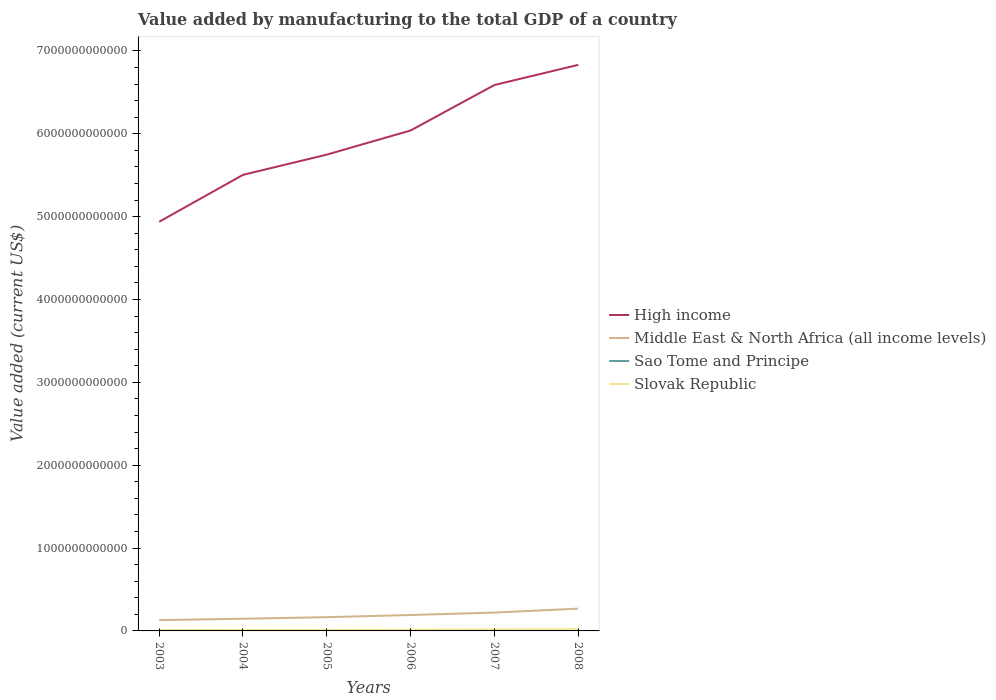How many different coloured lines are there?
Give a very brief answer. 4. Does the line corresponding to Sao Tome and Principe intersect with the line corresponding to Middle East & North Africa (all income levels)?
Keep it short and to the point. No. Is the number of lines equal to the number of legend labels?
Your response must be concise. Yes. Across all years, what is the maximum value added by manufacturing to the total GDP in High income?
Ensure brevity in your answer.  4.94e+12. What is the total value added by manufacturing to the total GDP in Sao Tome and Principe in the graph?
Your response must be concise. -6.07e+05. What is the difference between the highest and the second highest value added by manufacturing to the total GDP in Slovak Republic?
Give a very brief answer. 1.06e+1. How many years are there in the graph?
Provide a short and direct response. 6. What is the difference between two consecutive major ticks on the Y-axis?
Your answer should be compact. 1.00e+12. How many legend labels are there?
Give a very brief answer. 4. What is the title of the graph?
Your answer should be very brief. Value added by manufacturing to the total GDP of a country. What is the label or title of the X-axis?
Make the answer very short. Years. What is the label or title of the Y-axis?
Provide a short and direct response. Value added (current US$). What is the Value added (current US$) of High income in 2003?
Give a very brief answer. 4.94e+12. What is the Value added (current US$) in Middle East & North Africa (all income levels) in 2003?
Provide a short and direct response. 1.31e+11. What is the Value added (current US$) of Sao Tome and Principe in 2003?
Give a very brief answer. 6.55e+06. What is the Value added (current US$) of Slovak Republic in 2003?
Ensure brevity in your answer.  9.63e+09. What is the Value added (current US$) of High income in 2004?
Give a very brief answer. 5.50e+12. What is the Value added (current US$) in Middle East & North Africa (all income levels) in 2004?
Ensure brevity in your answer.  1.47e+11. What is the Value added (current US$) in Sao Tome and Principe in 2004?
Offer a very short reply. 6.38e+06. What is the Value added (current US$) in Slovak Republic in 2004?
Keep it short and to the point. 1.21e+1. What is the Value added (current US$) in High income in 2005?
Your answer should be very brief. 5.75e+12. What is the Value added (current US$) in Middle East & North Africa (all income levels) in 2005?
Keep it short and to the point. 1.66e+11. What is the Value added (current US$) of Sao Tome and Principe in 2005?
Provide a short and direct response. 6.79e+06. What is the Value added (current US$) of Slovak Republic in 2005?
Provide a short and direct response. 1.31e+1. What is the Value added (current US$) in High income in 2006?
Ensure brevity in your answer.  6.04e+12. What is the Value added (current US$) of Middle East & North Africa (all income levels) in 2006?
Provide a succinct answer. 1.92e+11. What is the Value added (current US$) in Sao Tome and Principe in 2006?
Offer a very short reply. 6.99e+06. What is the Value added (current US$) in Slovak Republic in 2006?
Ensure brevity in your answer.  1.49e+1. What is the Value added (current US$) of High income in 2007?
Provide a succinct answer. 6.59e+12. What is the Value added (current US$) in Middle East & North Africa (all income levels) in 2007?
Offer a very short reply. 2.21e+11. What is the Value added (current US$) in Sao Tome and Principe in 2007?
Provide a short and direct response. 7.11e+06. What is the Value added (current US$) of Slovak Republic in 2007?
Provide a short and direct response. 1.81e+1. What is the Value added (current US$) of High income in 2008?
Offer a very short reply. 6.83e+12. What is the Value added (current US$) in Middle East & North Africa (all income levels) in 2008?
Ensure brevity in your answer.  2.69e+11. What is the Value added (current US$) in Sao Tome and Principe in 2008?
Your answer should be very brief. 1.15e+07. What is the Value added (current US$) of Slovak Republic in 2008?
Your answer should be very brief. 2.03e+1. Across all years, what is the maximum Value added (current US$) of High income?
Provide a succinct answer. 6.83e+12. Across all years, what is the maximum Value added (current US$) of Middle East & North Africa (all income levels)?
Offer a terse response. 2.69e+11. Across all years, what is the maximum Value added (current US$) of Sao Tome and Principe?
Give a very brief answer. 1.15e+07. Across all years, what is the maximum Value added (current US$) in Slovak Republic?
Offer a very short reply. 2.03e+1. Across all years, what is the minimum Value added (current US$) in High income?
Offer a very short reply. 4.94e+12. Across all years, what is the minimum Value added (current US$) in Middle East & North Africa (all income levels)?
Keep it short and to the point. 1.31e+11. Across all years, what is the minimum Value added (current US$) of Sao Tome and Principe?
Provide a succinct answer. 6.38e+06. Across all years, what is the minimum Value added (current US$) in Slovak Republic?
Provide a short and direct response. 9.63e+09. What is the total Value added (current US$) of High income in the graph?
Your answer should be compact. 3.56e+13. What is the total Value added (current US$) in Middle East & North Africa (all income levels) in the graph?
Your answer should be compact. 1.13e+12. What is the total Value added (current US$) in Sao Tome and Principe in the graph?
Provide a short and direct response. 4.53e+07. What is the total Value added (current US$) of Slovak Republic in the graph?
Make the answer very short. 8.81e+1. What is the difference between the Value added (current US$) in High income in 2003 and that in 2004?
Offer a terse response. -5.66e+11. What is the difference between the Value added (current US$) in Middle East & North Africa (all income levels) in 2003 and that in 2004?
Your answer should be very brief. -1.64e+1. What is the difference between the Value added (current US$) in Sao Tome and Principe in 2003 and that in 2004?
Keep it short and to the point. 1.73e+05. What is the difference between the Value added (current US$) of Slovak Republic in 2003 and that in 2004?
Keep it short and to the point. -2.42e+09. What is the difference between the Value added (current US$) in High income in 2003 and that in 2005?
Make the answer very short. -8.10e+11. What is the difference between the Value added (current US$) in Middle East & North Africa (all income levels) in 2003 and that in 2005?
Provide a succinct answer. -3.54e+1. What is the difference between the Value added (current US$) of Sao Tome and Principe in 2003 and that in 2005?
Offer a very short reply. -2.34e+05. What is the difference between the Value added (current US$) of Slovak Republic in 2003 and that in 2005?
Make the answer very short. -3.47e+09. What is the difference between the Value added (current US$) of High income in 2003 and that in 2006?
Your answer should be compact. -1.10e+12. What is the difference between the Value added (current US$) of Middle East & North Africa (all income levels) in 2003 and that in 2006?
Make the answer very short. -6.12e+1. What is the difference between the Value added (current US$) in Sao Tome and Principe in 2003 and that in 2006?
Offer a very short reply. -4.34e+05. What is the difference between the Value added (current US$) in Slovak Republic in 2003 and that in 2006?
Keep it short and to the point. -5.31e+09. What is the difference between the Value added (current US$) in High income in 2003 and that in 2007?
Keep it short and to the point. -1.65e+12. What is the difference between the Value added (current US$) in Middle East & North Africa (all income levels) in 2003 and that in 2007?
Provide a short and direct response. -9.07e+1. What is the difference between the Value added (current US$) of Sao Tome and Principe in 2003 and that in 2007?
Offer a very short reply. -5.55e+05. What is the difference between the Value added (current US$) of Slovak Republic in 2003 and that in 2007?
Make the answer very short. -8.48e+09. What is the difference between the Value added (current US$) in High income in 2003 and that in 2008?
Provide a short and direct response. -1.89e+12. What is the difference between the Value added (current US$) in Middle East & North Africa (all income levels) in 2003 and that in 2008?
Ensure brevity in your answer.  -1.38e+11. What is the difference between the Value added (current US$) of Sao Tome and Principe in 2003 and that in 2008?
Keep it short and to the point. -4.90e+06. What is the difference between the Value added (current US$) in Slovak Republic in 2003 and that in 2008?
Offer a terse response. -1.06e+1. What is the difference between the Value added (current US$) of High income in 2004 and that in 2005?
Keep it short and to the point. -2.44e+11. What is the difference between the Value added (current US$) of Middle East & North Africa (all income levels) in 2004 and that in 2005?
Your answer should be very brief. -1.90e+1. What is the difference between the Value added (current US$) in Sao Tome and Principe in 2004 and that in 2005?
Offer a very short reply. -4.07e+05. What is the difference between the Value added (current US$) in Slovak Republic in 2004 and that in 2005?
Your response must be concise. -1.05e+09. What is the difference between the Value added (current US$) of High income in 2004 and that in 2006?
Provide a short and direct response. -5.35e+11. What is the difference between the Value added (current US$) of Middle East & North Africa (all income levels) in 2004 and that in 2006?
Your answer should be very brief. -4.48e+1. What is the difference between the Value added (current US$) in Sao Tome and Principe in 2004 and that in 2006?
Make the answer very short. -6.07e+05. What is the difference between the Value added (current US$) of Slovak Republic in 2004 and that in 2006?
Offer a very short reply. -2.88e+09. What is the difference between the Value added (current US$) in High income in 2004 and that in 2007?
Provide a succinct answer. -1.08e+12. What is the difference between the Value added (current US$) in Middle East & North Africa (all income levels) in 2004 and that in 2007?
Provide a succinct answer. -7.43e+1. What is the difference between the Value added (current US$) in Sao Tome and Principe in 2004 and that in 2007?
Provide a succinct answer. -7.28e+05. What is the difference between the Value added (current US$) in Slovak Republic in 2004 and that in 2007?
Provide a short and direct response. -6.06e+09. What is the difference between the Value added (current US$) of High income in 2004 and that in 2008?
Make the answer very short. -1.33e+12. What is the difference between the Value added (current US$) in Middle East & North Africa (all income levels) in 2004 and that in 2008?
Your answer should be compact. -1.22e+11. What is the difference between the Value added (current US$) of Sao Tome and Principe in 2004 and that in 2008?
Keep it short and to the point. -5.08e+06. What is the difference between the Value added (current US$) of Slovak Republic in 2004 and that in 2008?
Offer a terse response. -8.20e+09. What is the difference between the Value added (current US$) of High income in 2005 and that in 2006?
Your answer should be compact. -2.91e+11. What is the difference between the Value added (current US$) in Middle East & North Africa (all income levels) in 2005 and that in 2006?
Make the answer very short. -2.58e+1. What is the difference between the Value added (current US$) of Sao Tome and Principe in 2005 and that in 2006?
Your response must be concise. -2.00e+05. What is the difference between the Value added (current US$) of Slovak Republic in 2005 and that in 2006?
Provide a succinct answer. -1.83e+09. What is the difference between the Value added (current US$) of High income in 2005 and that in 2007?
Keep it short and to the point. -8.40e+11. What is the difference between the Value added (current US$) in Middle East & North Africa (all income levels) in 2005 and that in 2007?
Your response must be concise. -5.53e+1. What is the difference between the Value added (current US$) in Sao Tome and Principe in 2005 and that in 2007?
Your answer should be very brief. -3.21e+05. What is the difference between the Value added (current US$) of Slovak Republic in 2005 and that in 2007?
Offer a very short reply. -5.00e+09. What is the difference between the Value added (current US$) in High income in 2005 and that in 2008?
Offer a terse response. -1.08e+12. What is the difference between the Value added (current US$) in Middle East & North Africa (all income levels) in 2005 and that in 2008?
Offer a very short reply. -1.03e+11. What is the difference between the Value added (current US$) of Sao Tome and Principe in 2005 and that in 2008?
Offer a terse response. -4.67e+06. What is the difference between the Value added (current US$) of Slovak Republic in 2005 and that in 2008?
Provide a succinct answer. -7.15e+09. What is the difference between the Value added (current US$) of High income in 2006 and that in 2007?
Your answer should be very brief. -5.49e+11. What is the difference between the Value added (current US$) of Middle East & North Africa (all income levels) in 2006 and that in 2007?
Provide a succinct answer. -2.95e+1. What is the difference between the Value added (current US$) of Sao Tome and Principe in 2006 and that in 2007?
Your answer should be compact. -1.21e+05. What is the difference between the Value added (current US$) in Slovak Republic in 2006 and that in 2007?
Offer a very short reply. -3.17e+09. What is the difference between the Value added (current US$) of High income in 2006 and that in 2008?
Provide a succinct answer. -7.92e+11. What is the difference between the Value added (current US$) of Middle East & North Africa (all income levels) in 2006 and that in 2008?
Make the answer very short. -7.68e+1. What is the difference between the Value added (current US$) in Sao Tome and Principe in 2006 and that in 2008?
Offer a very short reply. -4.47e+06. What is the difference between the Value added (current US$) of Slovak Republic in 2006 and that in 2008?
Keep it short and to the point. -5.32e+09. What is the difference between the Value added (current US$) of High income in 2007 and that in 2008?
Keep it short and to the point. -2.43e+11. What is the difference between the Value added (current US$) of Middle East & North Africa (all income levels) in 2007 and that in 2008?
Keep it short and to the point. -4.74e+1. What is the difference between the Value added (current US$) in Sao Tome and Principe in 2007 and that in 2008?
Your answer should be very brief. -4.35e+06. What is the difference between the Value added (current US$) of Slovak Republic in 2007 and that in 2008?
Offer a very short reply. -2.14e+09. What is the difference between the Value added (current US$) in High income in 2003 and the Value added (current US$) in Middle East & North Africa (all income levels) in 2004?
Give a very brief answer. 4.79e+12. What is the difference between the Value added (current US$) in High income in 2003 and the Value added (current US$) in Sao Tome and Principe in 2004?
Your response must be concise. 4.94e+12. What is the difference between the Value added (current US$) of High income in 2003 and the Value added (current US$) of Slovak Republic in 2004?
Provide a short and direct response. 4.93e+12. What is the difference between the Value added (current US$) of Middle East & North Africa (all income levels) in 2003 and the Value added (current US$) of Sao Tome and Principe in 2004?
Make the answer very short. 1.31e+11. What is the difference between the Value added (current US$) of Middle East & North Africa (all income levels) in 2003 and the Value added (current US$) of Slovak Republic in 2004?
Your response must be concise. 1.19e+11. What is the difference between the Value added (current US$) of Sao Tome and Principe in 2003 and the Value added (current US$) of Slovak Republic in 2004?
Provide a short and direct response. -1.20e+1. What is the difference between the Value added (current US$) in High income in 2003 and the Value added (current US$) in Middle East & North Africa (all income levels) in 2005?
Your response must be concise. 4.77e+12. What is the difference between the Value added (current US$) of High income in 2003 and the Value added (current US$) of Sao Tome and Principe in 2005?
Make the answer very short. 4.94e+12. What is the difference between the Value added (current US$) in High income in 2003 and the Value added (current US$) in Slovak Republic in 2005?
Offer a very short reply. 4.92e+12. What is the difference between the Value added (current US$) in Middle East & North Africa (all income levels) in 2003 and the Value added (current US$) in Sao Tome and Principe in 2005?
Make the answer very short. 1.31e+11. What is the difference between the Value added (current US$) in Middle East & North Africa (all income levels) in 2003 and the Value added (current US$) in Slovak Republic in 2005?
Give a very brief answer. 1.18e+11. What is the difference between the Value added (current US$) in Sao Tome and Principe in 2003 and the Value added (current US$) in Slovak Republic in 2005?
Your response must be concise. -1.31e+1. What is the difference between the Value added (current US$) in High income in 2003 and the Value added (current US$) in Middle East & North Africa (all income levels) in 2006?
Your answer should be very brief. 4.75e+12. What is the difference between the Value added (current US$) of High income in 2003 and the Value added (current US$) of Sao Tome and Principe in 2006?
Make the answer very short. 4.94e+12. What is the difference between the Value added (current US$) in High income in 2003 and the Value added (current US$) in Slovak Republic in 2006?
Offer a very short reply. 4.92e+12. What is the difference between the Value added (current US$) in Middle East & North Africa (all income levels) in 2003 and the Value added (current US$) in Sao Tome and Principe in 2006?
Your answer should be very brief. 1.31e+11. What is the difference between the Value added (current US$) of Middle East & North Africa (all income levels) in 2003 and the Value added (current US$) of Slovak Republic in 2006?
Offer a terse response. 1.16e+11. What is the difference between the Value added (current US$) of Sao Tome and Principe in 2003 and the Value added (current US$) of Slovak Republic in 2006?
Your response must be concise. -1.49e+1. What is the difference between the Value added (current US$) in High income in 2003 and the Value added (current US$) in Middle East & North Africa (all income levels) in 2007?
Your answer should be very brief. 4.72e+12. What is the difference between the Value added (current US$) of High income in 2003 and the Value added (current US$) of Sao Tome and Principe in 2007?
Offer a terse response. 4.94e+12. What is the difference between the Value added (current US$) in High income in 2003 and the Value added (current US$) in Slovak Republic in 2007?
Your answer should be very brief. 4.92e+12. What is the difference between the Value added (current US$) of Middle East & North Africa (all income levels) in 2003 and the Value added (current US$) of Sao Tome and Principe in 2007?
Your answer should be very brief. 1.31e+11. What is the difference between the Value added (current US$) of Middle East & North Africa (all income levels) in 2003 and the Value added (current US$) of Slovak Republic in 2007?
Ensure brevity in your answer.  1.13e+11. What is the difference between the Value added (current US$) in Sao Tome and Principe in 2003 and the Value added (current US$) in Slovak Republic in 2007?
Your response must be concise. -1.81e+1. What is the difference between the Value added (current US$) in High income in 2003 and the Value added (current US$) in Middle East & North Africa (all income levels) in 2008?
Your response must be concise. 4.67e+12. What is the difference between the Value added (current US$) in High income in 2003 and the Value added (current US$) in Sao Tome and Principe in 2008?
Your answer should be compact. 4.94e+12. What is the difference between the Value added (current US$) in High income in 2003 and the Value added (current US$) in Slovak Republic in 2008?
Offer a very short reply. 4.92e+12. What is the difference between the Value added (current US$) in Middle East & North Africa (all income levels) in 2003 and the Value added (current US$) in Sao Tome and Principe in 2008?
Ensure brevity in your answer.  1.31e+11. What is the difference between the Value added (current US$) of Middle East & North Africa (all income levels) in 2003 and the Value added (current US$) of Slovak Republic in 2008?
Make the answer very short. 1.10e+11. What is the difference between the Value added (current US$) in Sao Tome and Principe in 2003 and the Value added (current US$) in Slovak Republic in 2008?
Your answer should be very brief. -2.02e+1. What is the difference between the Value added (current US$) of High income in 2004 and the Value added (current US$) of Middle East & North Africa (all income levels) in 2005?
Provide a succinct answer. 5.34e+12. What is the difference between the Value added (current US$) in High income in 2004 and the Value added (current US$) in Sao Tome and Principe in 2005?
Offer a terse response. 5.50e+12. What is the difference between the Value added (current US$) in High income in 2004 and the Value added (current US$) in Slovak Republic in 2005?
Your answer should be compact. 5.49e+12. What is the difference between the Value added (current US$) of Middle East & North Africa (all income levels) in 2004 and the Value added (current US$) of Sao Tome and Principe in 2005?
Keep it short and to the point. 1.47e+11. What is the difference between the Value added (current US$) in Middle East & North Africa (all income levels) in 2004 and the Value added (current US$) in Slovak Republic in 2005?
Offer a terse response. 1.34e+11. What is the difference between the Value added (current US$) in Sao Tome and Principe in 2004 and the Value added (current US$) in Slovak Republic in 2005?
Make the answer very short. -1.31e+1. What is the difference between the Value added (current US$) of High income in 2004 and the Value added (current US$) of Middle East & North Africa (all income levels) in 2006?
Provide a short and direct response. 5.31e+12. What is the difference between the Value added (current US$) in High income in 2004 and the Value added (current US$) in Sao Tome and Principe in 2006?
Your answer should be very brief. 5.50e+12. What is the difference between the Value added (current US$) of High income in 2004 and the Value added (current US$) of Slovak Republic in 2006?
Your answer should be very brief. 5.49e+12. What is the difference between the Value added (current US$) in Middle East & North Africa (all income levels) in 2004 and the Value added (current US$) in Sao Tome and Principe in 2006?
Your answer should be compact. 1.47e+11. What is the difference between the Value added (current US$) in Middle East & North Africa (all income levels) in 2004 and the Value added (current US$) in Slovak Republic in 2006?
Keep it short and to the point. 1.32e+11. What is the difference between the Value added (current US$) in Sao Tome and Principe in 2004 and the Value added (current US$) in Slovak Republic in 2006?
Offer a very short reply. -1.49e+1. What is the difference between the Value added (current US$) in High income in 2004 and the Value added (current US$) in Middle East & North Africa (all income levels) in 2007?
Give a very brief answer. 5.28e+12. What is the difference between the Value added (current US$) of High income in 2004 and the Value added (current US$) of Sao Tome and Principe in 2007?
Your answer should be very brief. 5.50e+12. What is the difference between the Value added (current US$) of High income in 2004 and the Value added (current US$) of Slovak Republic in 2007?
Offer a very short reply. 5.49e+12. What is the difference between the Value added (current US$) of Middle East & North Africa (all income levels) in 2004 and the Value added (current US$) of Sao Tome and Principe in 2007?
Provide a short and direct response. 1.47e+11. What is the difference between the Value added (current US$) in Middle East & North Africa (all income levels) in 2004 and the Value added (current US$) in Slovak Republic in 2007?
Keep it short and to the point. 1.29e+11. What is the difference between the Value added (current US$) of Sao Tome and Principe in 2004 and the Value added (current US$) of Slovak Republic in 2007?
Keep it short and to the point. -1.81e+1. What is the difference between the Value added (current US$) of High income in 2004 and the Value added (current US$) of Middle East & North Africa (all income levels) in 2008?
Keep it short and to the point. 5.24e+12. What is the difference between the Value added (current US$) in High income in 2004 and the Value added (current US$) in Sao Tome and Principe in 2008?
Provide a succinct answer. 5.50e+12. What is the difference between the Value added (current US$) in High income in 2004 and the Value added (current US$) in Slovak Republic in 2008?
Your answer should be compact. 5.48e+12. What is the difference between the Value added (current US$) in Middle East & North Africa (all income levels) in 2004 and the Value added (current US$) in Sao Tome and Principe in 2008?
Provide a succinct answer. 1.47e+11. What is the difference between the Value added (current US$) of Middle East & North Africa (all income levels) in 2004 and the Value added (current US$) of Slovak Republic in 2008?
Provide a succinct answer. 1.27e+11. What is the difference between the Value added (current US$) of Sao Tome and Principe in 2004 and the Value added (current US$) of Slovak Republic in 2008?
Provide a succinct answer. -2.02e+1. What is the difference between the Value added (current US$) in High income in 2005 and the Value added (current US$) in Middle East & North Africa (all income levels) in 2006?
Offer a very short reply. 5.56e+12. What is the difference between the Value added (current US$) of High income in 2005 and the Value added (current US$) of Sao Tome and Principe in 2006?
Provide a short and direct response. 5.75e+12. What is the difference between the Value added (current US$) in High income in 2005 and the Value added (current US$) in Slovak Republic in 2006?
Your response must be concise. 5.73e+12. What is the difference between the Value added (current US$) of Middle East & North Africa (all income levels) in 2005 and the Value added (current US$) of Sao Tome and Principe in 2006?
Make the answer very short. 1.66e+11. What is the difference between the Value added (current US$) of Middle East & North Africa (all income levels) in 2005 and the Value added (current US$) of Slovak Republic in 2006?
Provide a short and direct response. 1.51e+11. What is the difference between the Value added (current US$) in Sao Tome and Principe in 2005 and the Value added (current US$) in Slovak Republic in 2006?
Give a very brief answer. -1.49e+1. What is the difference between the Value added (current US$) of High income in 2005 and the Value added (current US$) of Middle East & North Africa (all income levels) in 2007?
Provide a succinct answer. 5.53e+12. What is the difference between the Value added (current US$) in High income in 2005 and the Value added (current US$) in Sao Tome and Principe in 2007?
Give a very brief answer. 5.75e+12. What is the difference between the Value added (current US$) in High income in 2005 and the Value added (current US$) in Slovak Republic in 2007?
Your answer should be very brief. 5.73e+12. What is the difference between the Value added (current US$) in Middle East & North Africa (all income levels) in 2005 and the Value added (current US$) in Sao Tome and Principe in 2007?
Keep it short and to the point. 1.66e+11. What is the difference between the Value added (current US$) of Middle East & North Africa (all income levels) in 2005 and the Value added (current US$) of Slovak Republic in 2007?
Ensure brevity in your answer.  1.48e+11. What is the difference between the Value added (current US$) of Sao Tome and Principe in 2005 and the Value added (current US$) of Slovak Republic in 2007?
Offer a very short reply. -1.81e+1. What is the difference between the Value added (current US$) in High income in 2005 and the Value added (current US$) in Middle East & North Africa (all income levels) in 2008?
Your answer should be very brief. 5.48e+12. What is the difference between the Value added (current US$) in High income in 2005 and the Value added (current US$) in Sao Tome and Principe in 2008?
Your response must be concise. 5.75e+12. What is the difference between the Value added (current US$) in High income in 2005 and the Value added (current US$) in Slovak Republic in 2008?
Offer a terse response. 5.73e+12. What is the difference between the Value added (current US$) in Middle East & North Africa (all income levels) in 2005 and the Value added (current US$) in Sao Tome and Principe in 2008?
Your answer should be compact. 1.66e+11. What is the difference between the Value added (current US$) in Middle East & North Africa (all income levels) in 2005 and the Value added (current US$) in Slovak Republic in 2008?
Ensure brevity in your answer.  1.46e+11. What is the difference between the Value added (current US$) of Sao Tome and Principe in 2005 and the Value added (current US$) of Slovak Republic in 2008?
Give a very brief answer. -2.02e+1. What is the difference between the Value added (current US$) in High income in 2006 and the Value added (current US$) in Middle East & North Africa (all income levels) in 2007?
Give a very brief answer. 5.82e+12. What is the difference between the Value added (current US$) of High income in 2006 and the Value added (current US$) of Sao Tome and Principe in 2007?
Your answer should be compact. 6.04e+12. What is the difference between the Value added (current US$) of High income in 2006 and the Value added (current US$) of Slovak Republic in 2007?
Your answer should be compact. 6.02e+12. What is the difference between the Value added (current US$) of Middle East & North Africa (all income levels) in 2006 and the Value added (current US$) of Sao Tome and Principe in 2007?
Make the answer very short. 1.92e+11. What is the difference between the Value added (current US$) of Middle East & North Africa (all income levels) in 2006 and the Value added (current US$) of Slovak Republic in 2007?
Ensure brevity in your answer.  1.74e+11. What is the difference between the Value added (current US$) in Sao Tome and Principe in 2006 and the Value added (current US$) in Slovak Republic in 2007?
Your answer should be compact. -1.81e+1. What is the difference between the Value added (current US$) of High income in 2006 and the Value added (current US$) of Middle East & North Africa (all income levels) in 2008?
Offer a very short reply. 5.77e+12. What is the difference between the Value added (current US$) in High income in 2006 and the Value added (current US$) in Sao Tome and Principe in 2008?
Keep it short and to the point. 6.04e+12. What is the difference between the Value added (current US$) of High income in 2006 and the Value added (current US$) of Slovak Republic in 2008?
Offer a terse response. 6.02e+12. What is the difference between the Value added (current US$) in Middle East & North Africa (all income levels) in 2006 and the Value added (current US$) in Sao Tome and Principe in 2008?
Make the answer very short. 1.92e+11. What is the difference between the Value added (current US$) in Middle East & North Africa (all income levels) in 2006 and the Value added (current US$) in Slovak Republic in 2008?
Provide a succinct answer. 1.72e+11. What is the difference between the Value added (current US$) of Sao Tome and Principe in 2006 and the Value added (current US$) of Slovak Republic in 2008?
Ensure brevity in your answer.  -2.02e+1. What is the difference between the Value added (current US$) of High income in 2007 and the Value added (current US$) of Middle East & North Africa (all income levels) in 2008?
Your response must be concise. 6.32e+12. What is the difference between the Value added (current US$) in High income in 2007 and the Value added (current US$) in Sao Tome and Principe in 2008?
Offer a very short reply. 6.59e+12. What is the difference between the Value added (current US$) in High income in 2007 and the Value added (current US$) in Slovak Republic in 2008?
Provide a short and direct response. 6.57e+12. What is the difference between the Value added (current US$) in Middle East & North Africa (all income levels) in 2007 and the Value added (current US$) in Sao Tome and Principe in 2008?
Your response must be concise. 2.21e+11. What is the difference between the Value added (current US$) in Middle East & North Africa (all income levels) in 2007 and the Value added (current US$) in Slovak Republic in 2008?
Offer a very short reply. 2.01e+11. What is the difference between the Value added (current US$) in Sao Tome and Principe in 2007 and the Value added (current US$) in Slovak Republic in 2008?
Offer a terse response. -2.02e+1. What is the average Value added (current US$) of High income per year?
Offer a very short reply. 5.94e+12. What is the average Value added (current US$) in Middle East & North Africa (all income levels) per year?
Your answer should be very brief. 1.88e+11. What is the average Value added (current US$) in Sao Tome and Principe per year?
Offer a terse response. 7.55e+06. What is the average Value added (current US$) in Slovak Republic per year?
Provide a succinct answer. 1.47e+1. In the year 2003, what is the difference between the Value added (current US$) in High income and Value added (current US$) in Middle East & North Africa (all income levels)?
Offer a very short reply. 4.81e+12. In the year 2003, what is the difference between the Value added (current US$) of High income and Value added (current US$) of Sao Tome and Principe?
Offer a very short reply. 4.94e+12. In the year 2003, what is the difference between the Value added (current US$) of High income and Value added (current US$) of Slovak Republic?
Give a very brief answer. 4.93e+12. In the year 2003, what is the difference between the Value added (current US$) of Middle East & North Africa (all income levels) and Value added (current US$) of Sao Tome and Principe?
Your answer should be very brief. 1.31e+11. In the year 2003, what is the difference between the Value added (current US$) of Middle East & North Africa (all income levels) and Value added (current US$) of Slovak Republic?
Offer a terse response. 1.21e+11. In the year 2003, what is the difference between the Value added (current US$) in Sao Tome and Principe and Value added (current US$) in Slovak Republic?
Your answer should be compact. -9.63e+09. In the year 2004, what is the difference between the Value added (current US$) in High income and Value added (current US$) in Middle East & North Africa (all income levels)?
Your answer should be compact. 5.36e+12. In the year 2004, what is the difference between the Value added (current US$) in High income and Value added (current US$) in Sao Tome and Principe?
Make the answer very short. 5.50e+12. In the year 2004, what is the difference between the Value added (current US$) in High income and Value added (current US$) in Slovak Republic?
Provide a short and direct response. 5.49e+12. In the year 2004, what is the difference between the Value added (current US$) of Middle East & North Africa (all income levels) and Value added (current US$) of Sao Tome and Principe?
Give a very brief answer. 1.47e+11. In the year 2004, what is the difference between the Value added (current US$) of Middle East & North Africa (all income levels) and Value added (current US$) of Slovak Republic?
Your answer should be very brief. 1.35e+11. In the year 2004, what is the difference between the Value added (current US$) in Sao Tome and Principe and Value added (current US$) in Slovak Republic?
Offer a very short reply. -1.20e+1. In the year 2005, what is the difference between the Value added (current US$) in High income and Value added (current US$) in Middle East & North Africa (all income levels)?
Your response must be concise. 5.58e+12. In the year 2005, what is the difference between the Value added (current US$) in High income and Value added (current US$) in Sao Tome and Principe?
Offer a terse response. 5.75e+12. In the year 2005, what is the difference between the Value added (current US$) in High income and Value added (current US$) in Slovak Republic?
Keep it short and to the point. 5.74e+12. In the year 2005, what is the difference between the Value added (current US$) in Middle East & North Africa (all income levels) and Value added (current US$) in Sao Tome and Principe?
Your answer should be very brief. 1.66e+11. In the year 2005, what is the difference between the Value added (current US$) of Middle East & North Africa (all income levels) and Value added (current US$) of Slovak Republic?
Offer a terse response. 1.53e+11. In the year 2005, what is the difference between the Value added (current US$) in Sao Tome and Principe and Value added (current US$) in Slovak Republic?
Your answer should be compact. -1.31e+1. In the year 2006, what is the difference between the Value added (current US$) in High income and Value added (current US$) in Middle East & North Africa (all income levels)?
Your answer should be compact. 5.85e+12. In the year 2006, what is the difference between the Value added (current US$) in High income and Value added (current US$) in Sao Tome and Principe?
Ensure brevity in your answer.  6.04e+12. In the year 2006, what is the difference between the Value added (current US$) in High income and Value added (current US$) in Slovak Republic?
Your response must be concise. 6.02e+12. In the year 2006, what is the difference between the Value added (current US$) of Middle East & North Africa (all income levels) and Value added (current US$) of Sao Tome and Principe?
Offer a very short reply. 1.92e+11. In the year 2006, what is the difference between the Value added (current US$) in Middle East & North Africa (all income levels) and Value added (current US$) in Slovak Republic?
Keep it short and to the point. 1.77e+11. In the year 2006, what is the difference between the Value added (current US$) of Sao Tome and Principe and Value added (current US$) of Slovak Republic?
Keep it short and to the point. -1.49e+1. In the year 2007, what is the difference between the Value added (current US$) in High income and Value added (current US$) in Middle East & North Africa (all income levels)?
Your response must be concise. 6.37e+12. In the year 2007, what is the difference between the Value added (current US$) in High income and Value added (current US$) in Sao Tome and Principe?
Ensure brevity in your answer.  6.59e+12. In the year 2007, what is the difference between the Value added (current US$) of High income and Value added (current US$) of Slovak Republic?
Offer a very short reply. 6.57e+12. In the year 2007, what is the difference between the Value added (current US$) in Middle East & North Africa (all income levels) and Value added (current US$) in Sao Tome and Principe?
Offer a very short reply. 2.21e+11. In the year 2007, what is the difference between the Value added (current US$) in Middle East & North Africa (all income levels) and Value added (current US$) in Slovak Republic?
Ensure brevity in your answer.  2.03e+11. In the year 2007, what is the difference between the Value added (current US$) in Sao Tome and Principe and Value added (current US$) in Slovak Republic?
Offer a terse response. -1.81e+1. In the year 2008, what is the difference between the Value added (current US$) of High income and Value added (current US$) of Middle East & North Africa (all income levels)?
Provide a succinct answer. 6.56e+12. In the year 2008, what is the difference between the Value added (current US$) of High income and Value added (current US$) of Sao Tome and Principe?
Your answer should be compact. 6.83e+12. In the year 2008, what is the difference between the Value added (current US$) in High income and Value added (current US$) in Slovak Republic?
Provide a short and direct response. 6.81e+12. In the year 2008, what is the difference between the Value added (current US$) of Middle East & North Africa (all income levels) and Value added (current US$) of Sao Tome and Principe?
Make the answer very short. 2.69e+11. In the year 2008, what is the difference between the Value added (current US$) in Middle East & North Africa (all income levels) and Value added (current US$) in Slovak Republic?
Your answer should be compact. 2.48e+11. In the year 2008, what is the difference between the Value added (current US$) in Sao Tome and Principe and Value added (current US$) in Slovak Republic?
Keep it short and to the point. -2.02e+1. What is the ratio of the Value added (current US$) of High income in 2003 to that in 2004?
Keep it short and to the point. 0.9. What is the ratio of the Value added (current US$) of Middle East & North Africa (all income levels) in 2003 to that in 2004?
Provide a short and direct response. 0.89. What is the ratio of the Value added (current US$) of Sao Tome and Principe in 2003 to that in 2004?
Provide a succinct answer. 1.03. What is the ratio of the Value added (current US$) of Slovak Republic in 2003 to that in 2004?
Your response must be concise. 0.8. What is the ratio of the Value added (current US$) in High income in 2003 to that in 2005?
Your response must be concise. 0.86. What is the ratio of the Value added (current US$) in Middle East & North Africa (all income levels) in 2003 to that in 2005?
Offer a terse response. 0.79. What is the ratio of the Value added (current US$) of Sao Tome and Principe in 2003 to that in 2005?
Offer a terse response. 0.97. What is the ratio of the Value added (current US$) in Slovak Republic in 2003 to that in 2005?
Your answer should be compact. 0.73. What is the ratio of the Value added (current US$) of High income in 2003 to that in 2006?
Your response must be concise. 0.82. What is the ratio of the Value added (current US$) in Middle East & North Africa (all income levels) in 2003 to that in 2006?
Offer a very short reply. 0.68. What is the ratio of the Value added (current US$) in Sao Tome and Principe in 2003 to that in 2006?
Give a very brief answer. 0.94. What is the ratio of the Value added (current US$) in Slovak Republic in 2003 to that in 2006?
Give a very brief answer. 0.64. What is the ratio of the Value added (current US$) in High income in 2003 to that in 2007?
Give a very brief answer. 0.75. What is the ratio of the Value added (current US$) in Middle East & North Africa (all income levels) in 2003 to that in 2007?
Give a very brief answer. 0.59. What is the ratio of the Value added (current US$) in Sao Tome and Principe in 2003 to that in 2007?
Ensure brevity in your answer.  0.92. What is the ratio of the Value added (current US$) of Slovak Republic in 2003 to that in 2007?
Make the answer very short. 0.53. What is the ratio of the Value added (current US$) in High income in 2003 to that in 2008?
Your answer should be compact. 0.72. What is the ratio of the Value added (current US$) of Middle East & North Africa (all income levels) in 2003 to that in 2008?
Keep it short and to the point. 0.49. What is the ratio of the Value added (current US$) of Sao Tome and Principe in 2003 to that in 2008?
Ensure brevity in your answer.  0.57. What is the ratio of the Value added (current US$) of Slovak Republic in 2003 to that in 2008?
Provide a short and direct response. 0.48. What is the ratio of the Value added (current US$) in High income in 2004 to that in 2005?
Keep it short and to the point. 0.96. What is the ratio of the Value added (current US$) of Middle East & North Africa (all income levels) in 2004 to that in 2005?
Ensure brevity in your answer.  0.89. What is the ratio of the Value added (current US$) of Sao Tome and Principe in 2004 to that in 2005?
Offer a very short reply. 0.94. What is the ratio of the Value added (current US$) of Slovak Republic in 2004 to that in 2005?
Offer a very short reply. 0.92. What is the ratio of the Value added (current US$) in High income in 2004 to that in 2006?
Your response must be concise. 0.91. What is the ratio of the Value added (current US$) in Middle East & North Africa (all income levels) in 2004 to that in 2006?
Offer a terse response. 0.77. What is the ratio of the Value added (current US$) in Sao Tome and Principe in 2004 to that in 2006?
Offer a terse response. 0.91. What is the ratio of the Value added (current US$) in Slovak Republic in 2004 to that in 2006?
Make the answer very short. 0.81. What is the ratio of the Value added (current US$) of High income in 2004 to that in 2007?
Offer a very short reply. 0.84. What is the ratio of the Value added (current US$) of Middle East & North Africa (all income levels) in 2004 to that in 2007?
Give a very brief answer. 0.66. What is the ratio of the Value added (current US$) in Sao Tome and Principe in 2004 to that in 2007?
Keep it short and to the point. 0.9. What is the ratio of the Value added (current US$) of Slovak Republic in 2004 to that in 2007?
Offer a terse response. 0.67. What is the ratio of the Value added (current US$) of High income in 2004 to that in 2008?
Provide a short and direct response. 0.81. What is the ratio of the Value added (current US$) of Middle East & North Africa (all income levels) in 2004 to that in 2008?
Provide a short and direct response. 0.55. What is the ratio of the Value added (current US$) in Sao Tome and Principe in 2004 to that in 2008?
Your response must be concise. 0.56. What is the ratio of the Value added (current US$) of Slovak Republic in 2004 to that in 2008?
Ensure brevity in your answer.  0.6. What is the ratio of the Value added (current US$) of High income in 2005 to that in 2006?
Offer a very short reply. 0.95. What is the ratio of the Value added (current US$) in Middle East & North Africa (all income levels) in 2005 to that in 2006?
Provide a short and direct response. 0.87. What is the ratio of the Value added (current US$) in Sao Tome and Principe in 2005 to that in 2006?
Keep it short and to the point. 0.97. What is the ratio of the Value added (current US$) in Slovak Republic in 2005 to that in 2006?
Offer a very short reply. 0.88. What is the ratio of the Value added (current US$) of High income in 2005 to that in 2007?
Keep it short and to the point. 0.87. What is the ratio of the Value added (current US$) of Middle East & North Africa (all income levels) in 2005 to that in 2007?
Your answer should be very brief. 0.75. What is the ratio of the Value added (current US$) of Sao Tome and Principe in 2005 to that in 2007?
Give a very brief answer. 0.95. What is the ratio of the Value added (current US$) in Slovak Republic in 2005 to that in 2007?
Provide a short and direct response. 0.72. What is the ratio of the Value added (current US$) of High income in 2005 to that in 2008?
Provide a succinct answer. 0.84. What is the ratio of the Value added (current US$) in Middle East & North Africa (all income levels) in 2005 to that in 2008?
Ensure brevity in your answer.  0.62. What is the ratio of the Value added (current US$) of Sao Tome and Principe in 2005 to that in 2008?
Give a very brief answer. 0.59. What is the ratio of the Value added (current US$) in Slovak Republic in 2005 to that in 2008?
Keep it short and to the point. 0.65. What is the ratio of the Value added (current US$) in Middle East & North Africa (all income levels) in 2006 to that in 2007?
Offer a very short reply. 0.87. What is the ratio of the Value added (current US$) of Sao Tome and Principe in 2006 to that in 2007?
Keep it short and to the point. 0.98. What is the ratio of the Value added (current US$) of Slovak Republic in 2006 to that in 2007?
Give a very brief answer. 0.82. What is the ratio of the Value added (current US$) in High income in 2006 to that in 2008?
Your answer should be compact. 0.88. What is the ratio of the Value added (current US$) in Middle East & North Africa (all income levels) in 2006 to that in 2008?
Give a very brief answer. 0.71. What is the ratio of the Value added (current US$) in Sao Tome and Principe in 2006 to that in 2008?
Make the answer very short. 0.61. What is the ratio of the Value added (current US$) of Slovak Republic in 2006 to that in 2008?
Your answer should be compact. 0.74. What is the ratio of the Value added (current US$) of High income in 2007 to that in 2008?
Make the answer very short. 0.96. What is the ratio of the Value added (current US$) of Middle East & North Africa (all income levels) in 2007 to that in 2008?
Provide a succinct answer. 0.82. What is the ratio of the Value added (current US$) of Sao Tome and Principe in 2007 to that in 2008?
Give a very brief answer. 0.62. What is the ratio of the Value added (current US$) in Slovak Republic in 2007 to that in 2008?
Make the answer very short. 0.89. What is the difference between the highest and the second highest Value added (current US$) in High income?
Provide a short and direct response. 2.43e+11. What is the difference between the highest and the second highest Value added (current US$) in Middle East & North Africa (all income levels)?
Make the answer very short. 4.74e+1. What is the difference between the highest and the second highest Value added (current US$) of Sao Tome and Principe?
Your answer should be compact. 4.35e+06. What is the difference between the highest and the second highest Value added (current US$) of Slovak Republic?
Keep it short and to the point. 2.14e+09. What is the difference between the highest and the lowest Value added (current US$) in High income?
Offer a very short reply. 1.89e+12. What is the difference between the highest and the lowest Value added (current US$) of Middle East & North Africa (all income levels)?
Keep it short and to the point. 1.38e+11. What is the difference between the highest and the lowest Value added (current US$) in Sao Tome and Principe?
Offer a terse response. 5.08e+06. What is the difference between the highest and the lowest Value added (current US$) of Slovak Republic?
Your answer should be compact. 1.06e+1. 